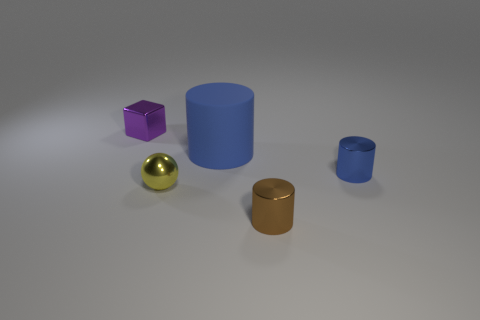Subtract all tiny brown shiny cylinders. How many cylinders are left? 2 Subtract all cyan spheres. How many blue cylinders are left? 2 Add 1 tiny yellow shiny cubes. How many objects exist? 6 Subtract all brown cylinders. How many cylinders are left? 2 Subtract all red cylinders. Subtract all yellow blocks. How many cylinders are left? 3 Add 2 large cylinders. How many large cylinders are left? 3 Add 1 large brown cubes. How many large brown cubes exist? 1 Subtract 0 red spheres. How many objects are left? 5 Subtract all cylinders. How many objects are left? 2 Subtract all small gray cylinders. Subtract all purple objects. How many objects are left? 4 